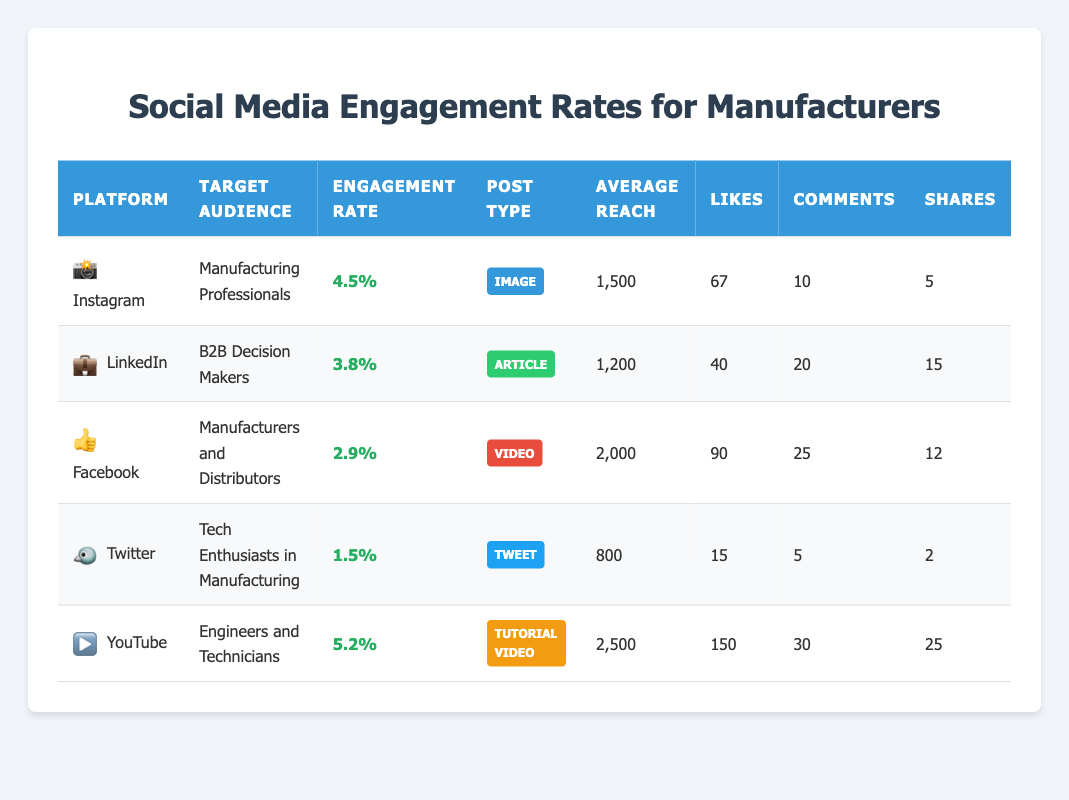What is the engagement rate for YouTube? The engagement rate for YouTube is directly listed in the table under the "Engagement Rate" column for the YouTube row, which is 5.2%.
Answer: 5.2% Which social media platform has the highest engagement rate for its target audience? By comparing the engagement rates across the platforms listed, I see that YouTube has the highest engagement rate at 5.2%.
Answer: YouTube How many likes did Facebook receive for its video posts? The number of likes Facebook received is found in the "Likes" column for the Facebook row, which shows 90 likes.
Answer: 90 What is the average engagement rate of Instagram and LinkedIn? The engagement rates for Instagram and LinkedIn are 4.5% and 3.8%, respectively. To find the average, I sum these values: (4.5 + 3.8) = 8.3, then divide by the number of platforms (2), resulting in 8.3 / 2 = 4.15%.
Answer: 4.15% Is the engagement rate for Twitter higher than that for Facebook? Twitter has an engagement rate of 1.5% while Facebook has an engagement rate of 2.9%. Since 1.5% is less than 2.9%, the answer is no.
Answer: No How many total shares were generated across all platforms? To find the total shares, I look at the shares column and sum them: 5 (Instagram) + 15 (LinkedIn) + 12 (Facebook) + 2 (Twitter) + 25 (YouTube) = 59 shares in total.
Answer: 59 What type of post received the most engagement on YouTube? Looking at YouTube's row, the post type listed is "Tutorial Video," which corresponds to its engagement rate of 5.2%.
Answer: Tutorial Video Did Instagram have a higher average reach than Twitter? Instagram's average reach is 1500, while Twitter's is 800. Since 1500 is greater than 800, the answer is yes.
Answer: Yes What is the combined number of comments received on LinkedIn and YouTube? LinkedIn received 20 comments and YouTube received 30 comments. Adding them together gives 20 + 30 = 50 comments in total.
Answer: 50 